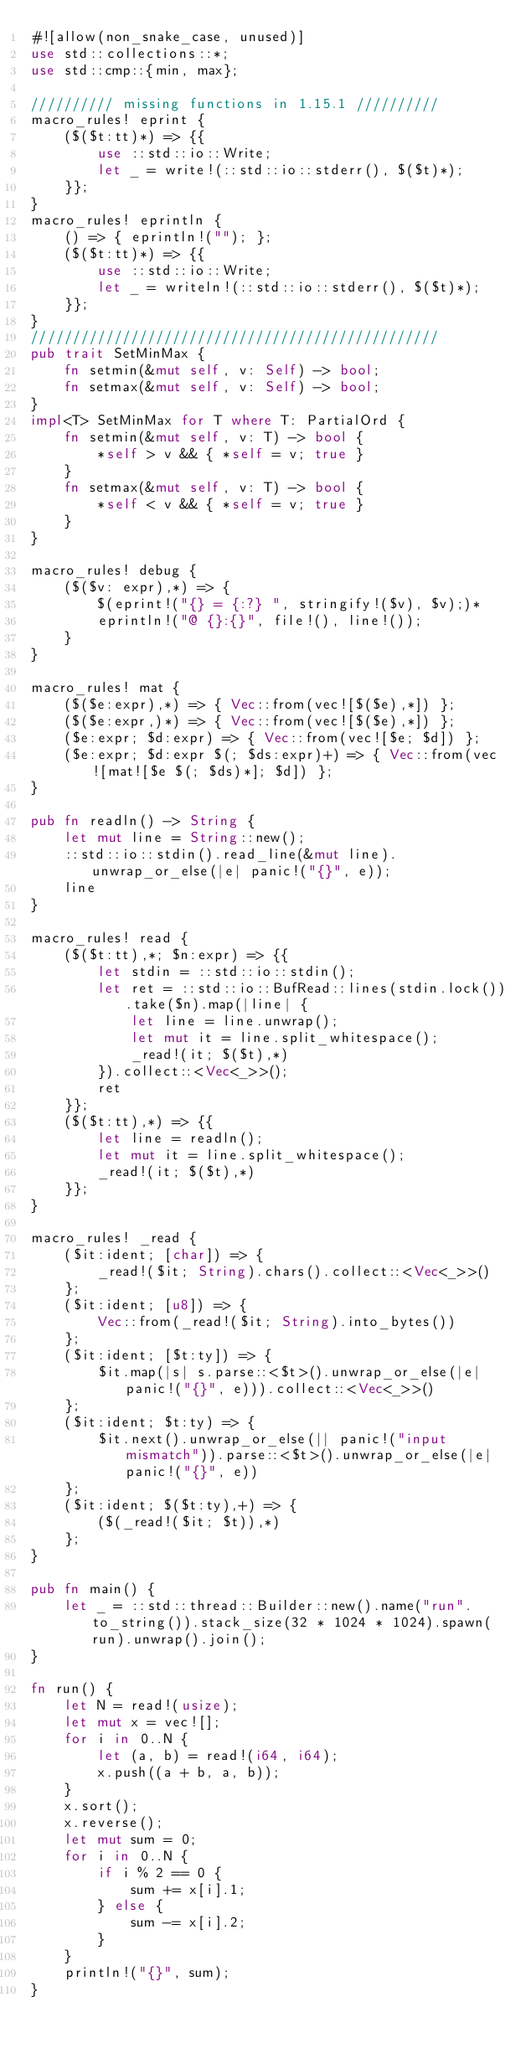<code> <loc_0><loc_0><loc_500><loc_500><_Rust_>#![allow(non_snake_case, unused)]
use std::collections::*;
use std::cmp::{min, max};

////////// missing functions in 1.15.1 //////////
macro_rules! eprint {
	($($t:tt)*) => {{
		use ::std::io::Write;
		let _ = write!(::std::io::stderr(), $($t)*);
	}};
}
macro_rules! eprintln {
	() => { eprintln!(""); };
	($($t:tt)*) => {{
		use ::std::io::Write;
		let _ = writeln!(::std::io::stderr(), $($t)*);
	}};
}
/////////////////////////////////////////////////
pub trait SetMinMax {
	fn setmin(&mut self, v: Self) -> bool;
	fn setmax(&mut self, v: Self) -> bool;
}
impl<T> SetMinMax for T where T: PartialOrd {
	fn setmin(&mut self, v: T) -> bool {
		*self > v && { *self = v; true }
	}
	fn setmax(&mut self, v: T) -> bool {
		*self < v && { *self = v; true }
	}
}

macro_rules! debug {
	($($v: expr),*) => {
		$(eprint!("{} = {:?} ", stringify!($v), $v);)*
		eprintln!("@ {}:{}", file!(), line!());
	}
}

macro_rules! mat {
	($($e:expr),*) => { Vec::from(vec![$($e),*]) };
	($($e:expr,)*) => { Vec::from(vec![$($e),*]) };
	($e:expr; $d:expr) => { Vec::from(vec![$e; $d]) };
	($e:expr; $d:expr $(; $ds:expr)+) => { Vec::from(vec![mat![$e $(; $ds)*]; $d]) };
}

pub fn readln() -> String {
	let mut line = String::new();
	::std::io::stdin().read_line(&mut line).unwrap_or_else(|e| panic!("{}", e));
	line
}

macro_rules! read {
	($($t:tt),*; $n:expr) => {{
		let stdin = ::std::io::stdin();
		let ret = ::std::io::BufRead::lines(stdin.lock()).take($n).map(|line| {
			let line = line.unwrap();
			let mut it = line.split_whitespace();
			_read!(it; $($t),*)
		}).collect::<Vec<_>>();
		ret
	}};
	($($t:tt),*) => {{
		let line = readln();
		let mut it = line.split_whitespace();
		_read!(it; $($t),*)
	}};
}

macro_rules! _read {
	($it:ident; [char]) => {
		_read!($it; String).chars().collect::<Vec<_>>()
	};
	($it:ident; [u8]) => {
		Vec::from(_read!($it; String).into_bytes())
	};
	($it:ident; [$t:ty]) => {
		$it.map(|s| s.parse::<$t>().unwrap_or_else(|e| panic!("{}", e))).collect::<Vec<_>>()
	};
	($it:ident; $t:ty) => {
		$it.next().unwrap_or_else(|| panic!("input mismatch")).parse::<$t>().unwrap_or_else(|e| panic!("{}", e))
	};
	($it:ident; $($t:ty),+) => {
		($(_read!($it; $t)),*)
	};
}

pub fn main() {
	let _ = ::std::thread::Builder::new().name("run".to_string()).stack_size(32 * 1024 * 1024).spawn(run).unwrap().join();
}

fn run() {
	let N = read!(usize);
	let mut x = vec![];
	for i in 0..N {
		let (a, b) = read!(i64, i64);
		x.push((a + b, a, b));
	}
	x.sort();
	x.reverse();
	let mut sum = 0;
	for i in 0..N {
		if i % 2 == 0 {
			sum += x[i].1;
		} else {
			sum -= x[i].2;
		}
	}
	println!("{}", sum);
}
</code> 